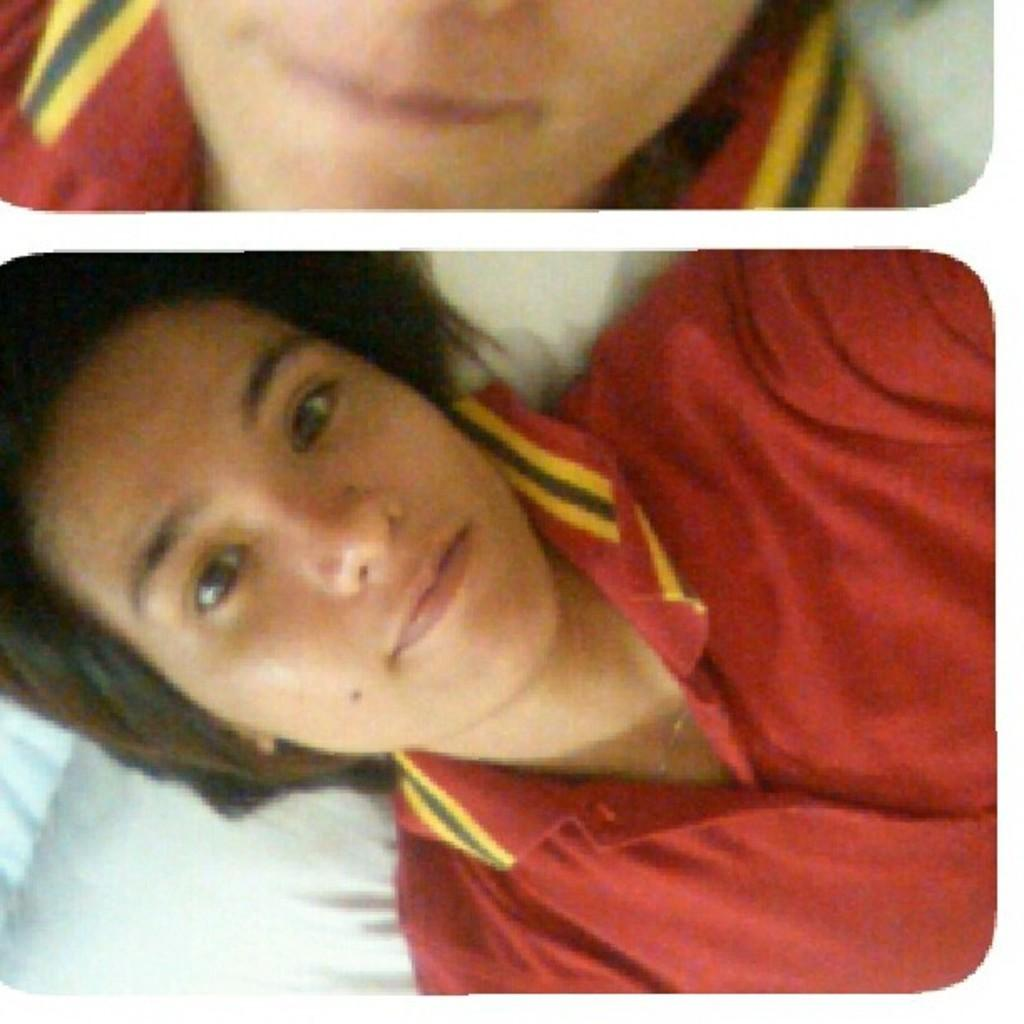What is the composition of the image? The image is a collage of two pictures. What is happening in the first picture? There is a woman laying on a bed in one of the pictures. What is happening in the second picture? The woman's mouth is visible in another picture. How many men are holding wine glasses in the image? There are no men or wine glasses present in the image. Are there any spiders crawling on the woman's face in the image? There are no spiders visible in the image. 